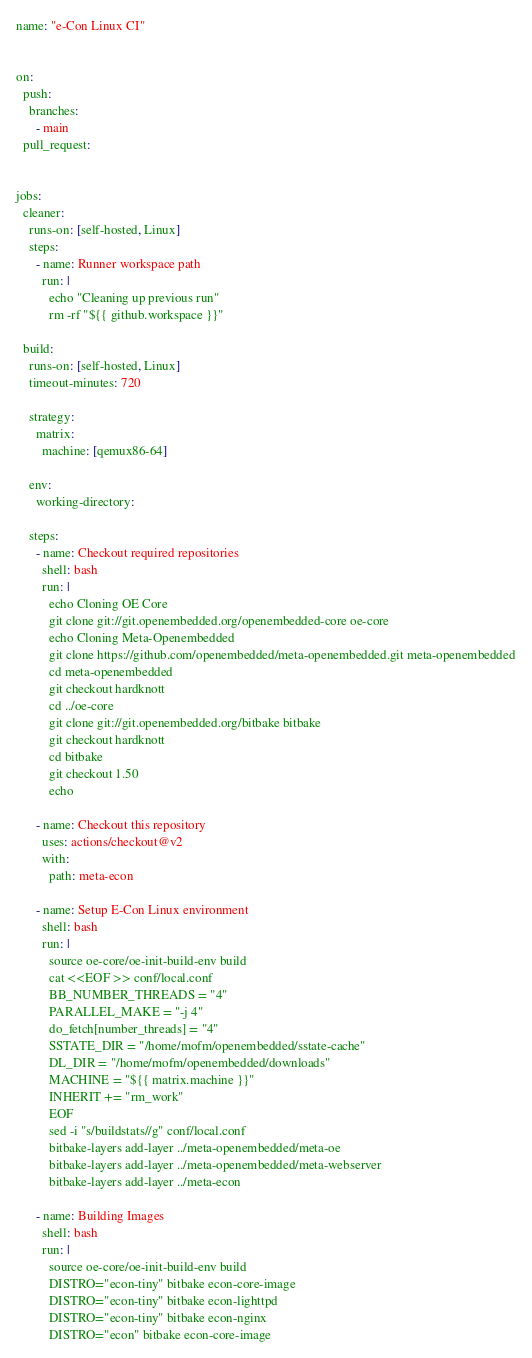Convert code to text. <code><loc_0><loc_0><loc_500><loc_500><_YAML_>name: "e-Con Linux CI"


on:
  push:
    branches:
      - main
  pull_request:


jobs:
  cleaner:
    runs-on: [self-hosted, Linux]
    steps:
      - name: Runner workspace path
        run: |
          echo "Cleaning up previous run"
          rm -rf "${{ github.workspace }}"

  build:
    runs-on: [self-hosted, Linux]
    timeout-minutes: 720

    strategy:
      matrix:
        machine: [qemux86-64]

    env:
      working-directory:

    steps:
      - name: Checkout required repositories
        shell: bash
        run: |
          echo Cloning OE Core
          git clone git://git.openembedded.org/openembedded-core oe-core
          echo Cloning Meta-Openembedded
          git clone https://github.com/openembedded/meta-openembedded.git meta-openembedded
          cd meta-openembedded
          git checkout hardknott
          cd ../oe-core
          git clone git://git.openembedded.org/bitbake bitbake
          git checkout hardknott
          cd bitbake
          git checkout 1.50
          echo

      - name: Checkout this repository
        uses: actions/checkout@v2
        with:
          path: meta-econ

      - name: Setup E-Con Linux environment
        shell: bash
        run: |
          source oe-core/oe-init-build-env build
          cat <<EOF >> conf/local.conf
          BB_NUMBER_THREADS = "4"
          PARALLEL_MAKE = "-j 4"
          do_fetch[number_threads] = "4"
          SSTATE_DIR = "/home/mofm/openembedded/sstate-cache"
          DL_DIR = "/home/mofm/openembedded/downloads"
          MACHINE = "${{ matrix.machine }}"
          INHERIT += "rm_work"
          EOF
          sed -i "s/buildstats//g" conf/local.conf
          bitbake-layers add-layer ../meta-openembedded/meta-oe
          bitbake-layers add-layer ../meta-openembedded/meta-webserver
          bitbake-layers add-layer ../meta-econ

      - name: Building Images
        shell: bash
        run: |
          source oe-core/oe-init-build-env build
          DISTRO="econ-tiny" bitbake econ-core-image
          DISTRO="econ-tiny" bitbake econ-lighttpd
          DISTRO="econ-tiny" bitbake econ-nginx
          DISTRO="econ" bitbake econ-core-image

</code> 